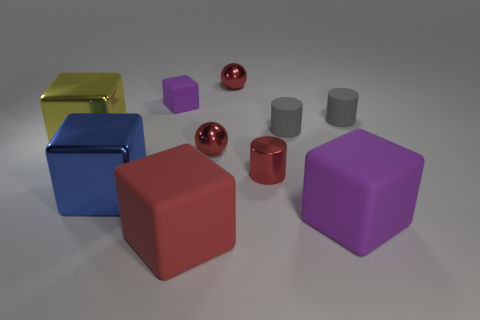There is a red matte thing that is the same shape as the yellow metallic object; what is its size?
Offer a terse response. Large. What number of other things are there of the same color as the tiny rubber cube?
Provide a succinct answer. 1. What material is the large purple object that is the same shape as the big red rubber object?
Your answer should be very brief. Rubber. What number of spheres have the same size as the red cube?
Ensure brevity in your answer.  0. Is the size of the red matte cube the same as the yellow cube?
Provide a succinct answer. Yes. There is a block that is both behind the blue block and on the right side of the big yellow thing; how big is it?
Give a very brief answer. Small. Is the number of purple things that are right of the small metal cylinder greater than the number of yellow metallic blocks that are right of the big red block?
Provide a short and direct response. Yes. There is another shiny thing that is the same shape as the yellow shiny object; what is its color?
Offer a terse response. Blue. There is a big shiny cube on the left side of the blue cube; does it have the same color as the small rubber block?
Offer a very short reply. No. What number of large blue blocks are there?
Your answer should be compact. 1. 